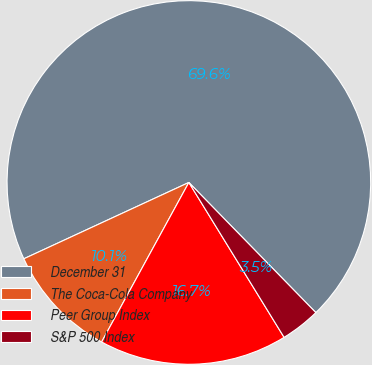<chart> <loc_0><loc_0><loc_500><loc_500><pie_chart><fcel>December 31<fcel>The Coca-Cola Company<fcel>Peer Group Index<fcel>S&P 500 Index<nl><fcel>69.59%<fcel>10.14%<fcel>16.74%<fcel>3.53%<nl></chart> 